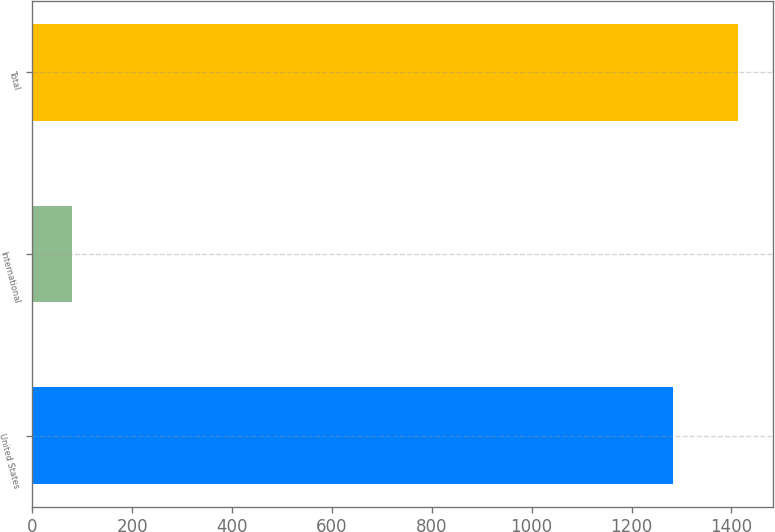<chart> <loc_0><loc_0><loc_500><loc_500><bar_chart><fcel>United States<fcel>International<fcel>Total<nl><fcel>1283.8<fcel>80.3<fcel>1412.18<nl></chart> 